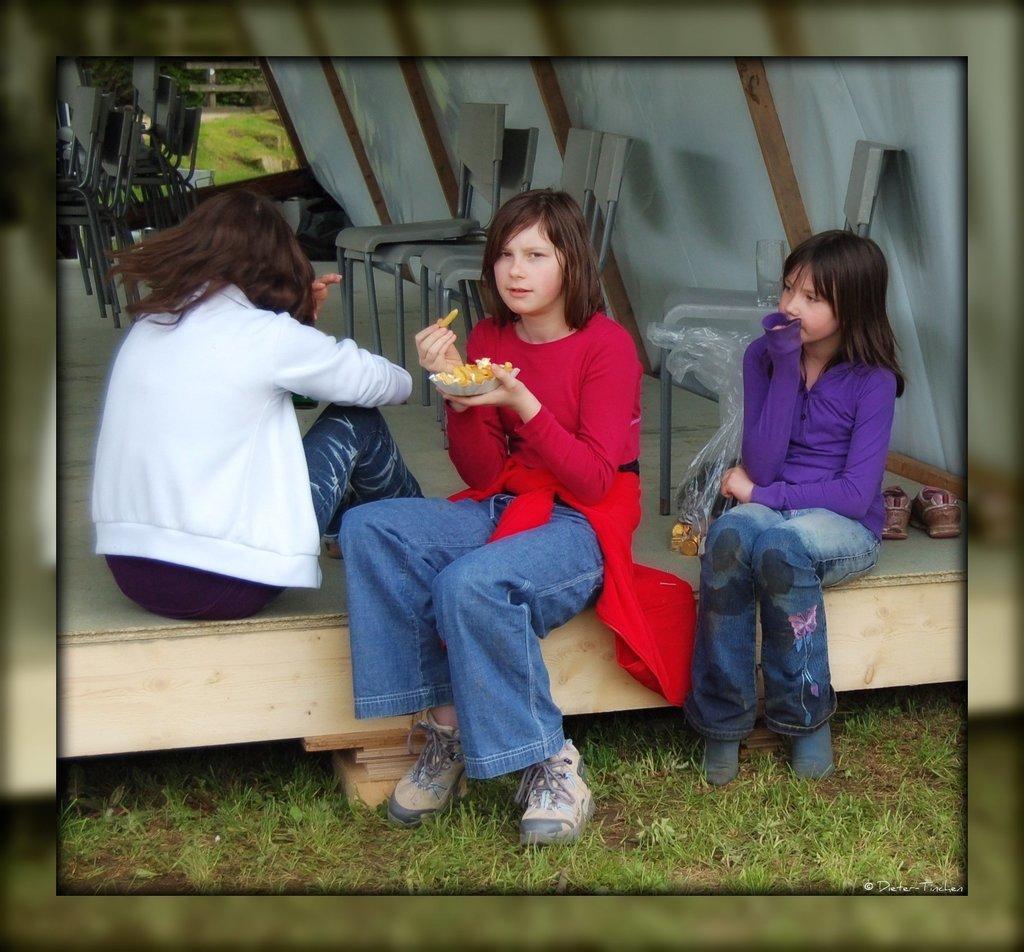How would you summarize this image in a sentence or two? This image is taken outdoors. At the bottom of the image there is a ground with grass on it. In the middle of the image there is a wooden dais and there are many empty chairs on the dais. Three girls are sitting on the dais and having snacks. 